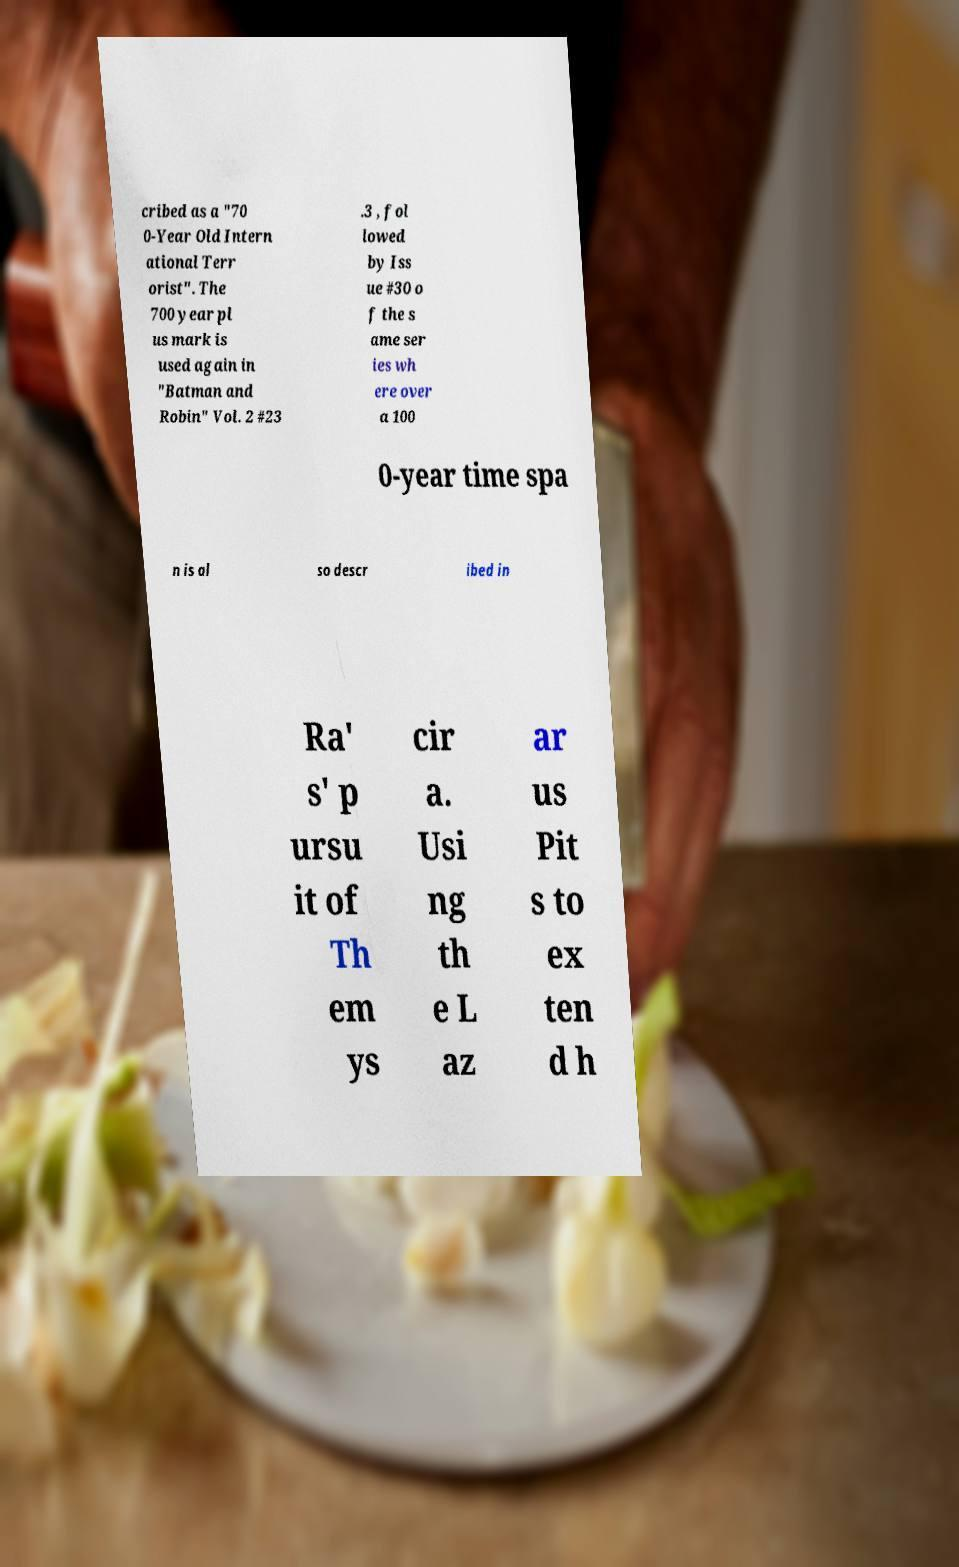For documentation purposes, I need the text within this image transcribed. Could you provide that? cribed as a "70 0-Year Old Intern ational Terr orist". The 700 year pl us mark is used again in "Batman and Robin" Vol. 2 #23 .3 , fol lowed by Iss ue #30 o f the s ame ser ies wh ere over a 100 0-year time spa n is al so descr ibed in Ra' s' p ursu it of Th em ys cir a. Usi ng th e L az ar us Pit s to ex ten d h 